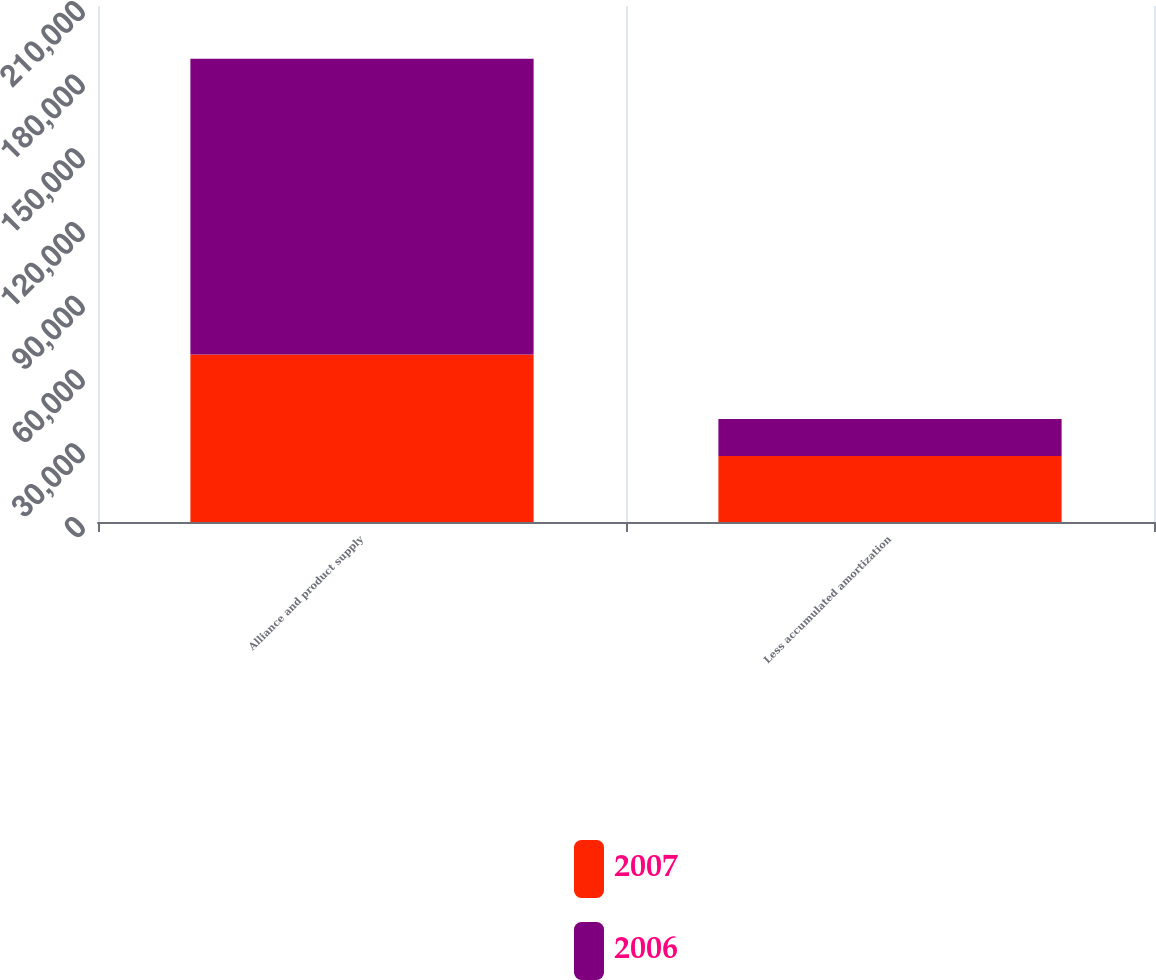<chart> <loc_0><loc_0><loc_500><loc_500><stacked_bar_chart><ecel><fcel>Alliance and product supply<fcel>Less accumulated amortization<nl><fcel>2007<fcel>68200<fcel>26893<nl><fcel>2006<fcel>120300<fcel>15037<nl></chart> 